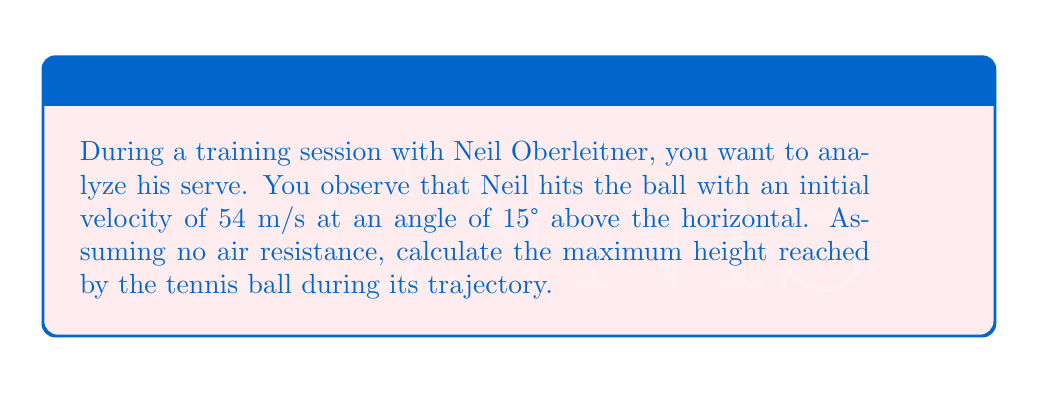What is the answer to this math problem? To solve this problem, we'll use the equations of motion for projectile motion. Let's break it down step-by-step:

1) First, we need to find the vertical component of the initial velocity:
   $v_{y0} = v_0 \sin \theta = 54 \cdot \sin 15° = 13.97 \text{ m/s}$

2) The maximum height is reached when the vertical velocity becomes zero. We can use the equation:
   $v_y^2 = v_{y0}^2 - 2gh_{max}$

   Where:
   $v_y = 0$ (at the highest point)
   $v_{y0} = 13.97 \text{ m/s}$
   $g = 9.8 \text{ m/s}^2$ (acceleration due to gravity)
   $h_{max}$ is what we're solving for

3) Substituting these values:
   $0^2 = 13.97^2 - 2(9.8)h_{max}$

4) Simplifying:
   $195.16 = 19.6h_{max}$

5) Solving for $h_{max}$:
   $$h_{max} = \frac{195.16}{19.6} = 9.96 \text{ m}$$

Therefore, the maximum height reached by the tennis ball is approximately 9.96 meters.
Answer: 9.96 meters 